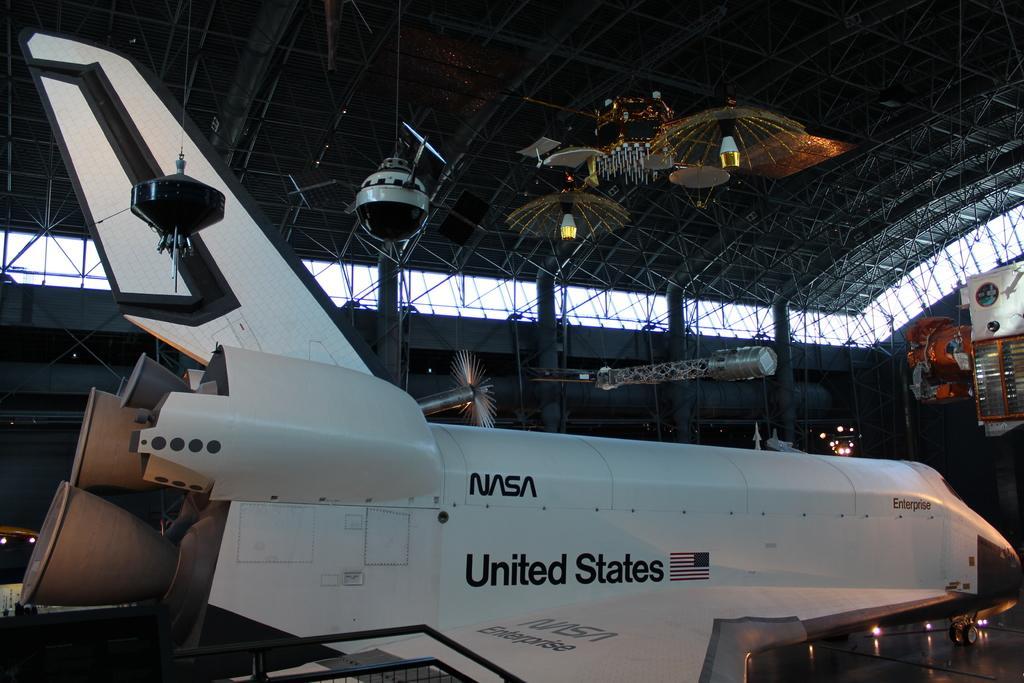Please provide a concise description of this image. Here we can see an airplane on the floor. There are poles, lights, and objects. 